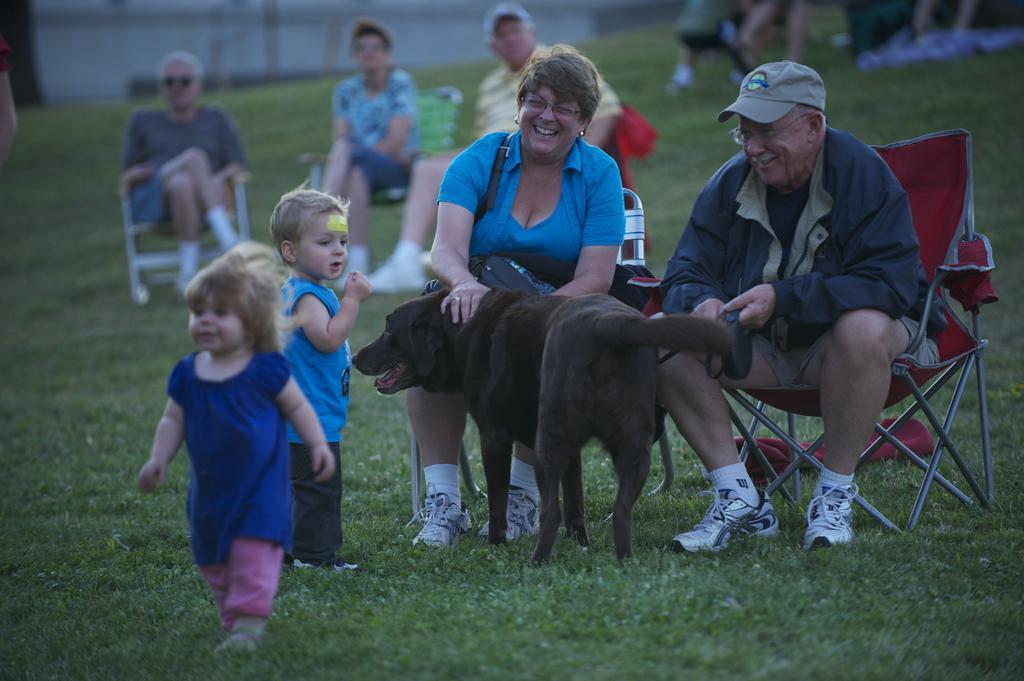Can you describe this image briefly? In this image I see a man and a woman who are sitting on chairs and both of them are smiling. I can also see 2 children and a dog on the grass. In the background I see few people who are sitting on chairs. 